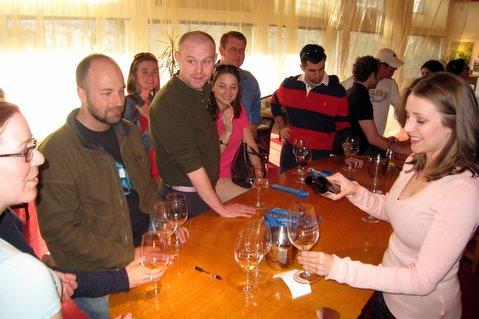Do they all look old enough to be drinking?
Quick response, please. Yes. How many people are in the picture?
Quick response, please. 12. Where is the woman holding a wine glass in her right hand?
Keep it brief. Left. Are all the glasses the same?
Quick response, please. Yes. Are they having a party?
Be succinct. Yes. Are the glasses full?
Quick response, please. No. Will it take more than 1 bottle of liquid to fill all of the glasses?
Write a very short answer. Yes. Is the woman wearing earrings?
Short answer required. No. What are they drinking?
Be succinct. Wine. 